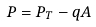<formula> <loc_0><loc_0><loc_500><loc_500>P = P _ { T } - q A</formula> 